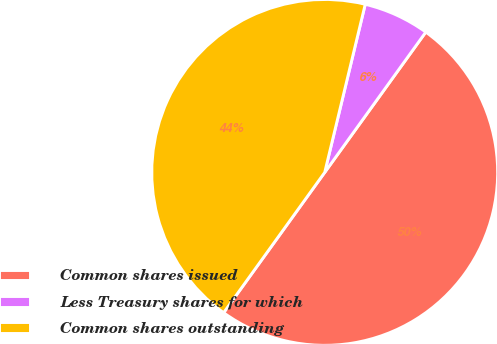Convert chart to OTSL. <chart><loc_0><loc_0><loc_500><loc_500><pie_chart><fcel>Common shares issued<fcel>Less Treasury shares for which<fcel>Common shares outstanding<nl><fcel>50.0%<fcel>6.17%<fcel>43.83%<nl></chart> 